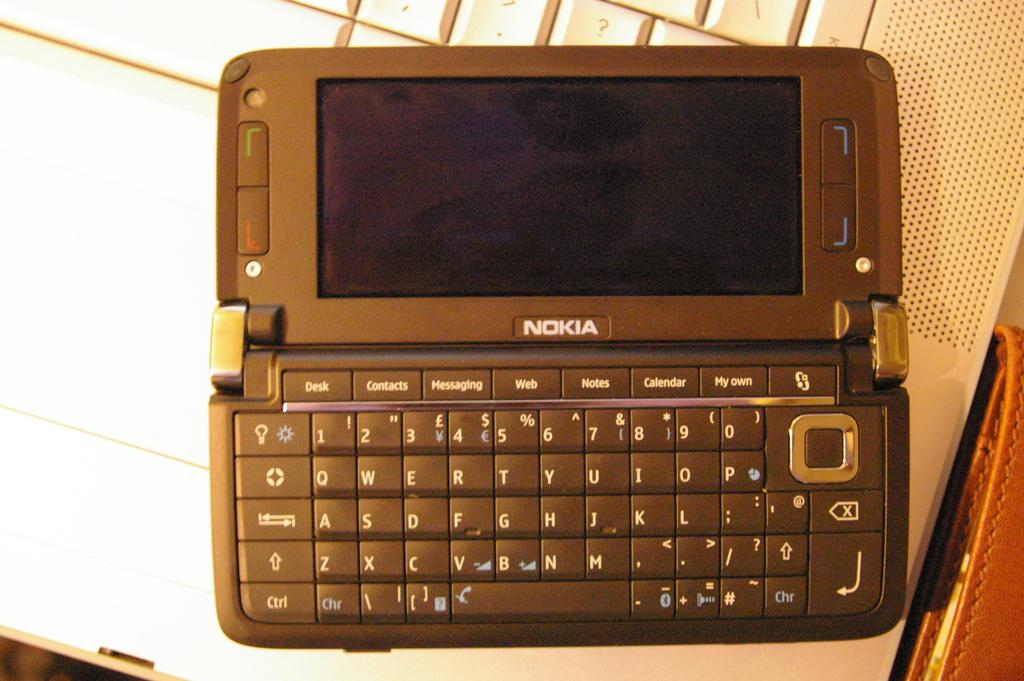<image>
Provide a brief description of the given image. A Nokia slider phone with a full qwerty keyboard. 